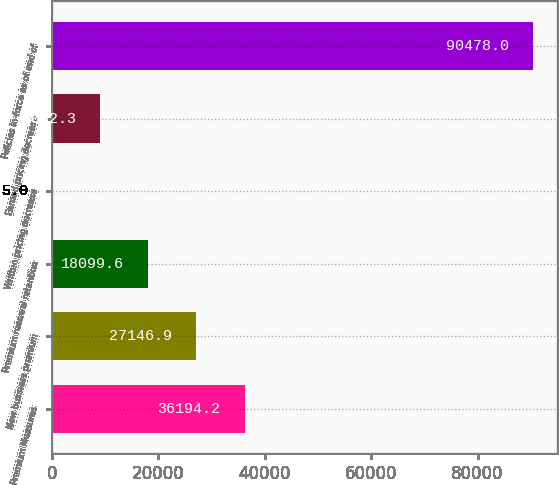<chart> <loc_0><loc_0><loc_500><loc_500><bar_chart><fcel>Premium Measures<fcel>New business premium<fcel>Premium renewal retention<fcel>Written pricing decrease<fcel>Earned pricing decrease<fcel>Policies in-force as of end of<nl><fcel>36194.2<fcel>27146.9<fcel>18099.6<fcel>5<fcel>9052.3<fcel>90478<nl></chart> 